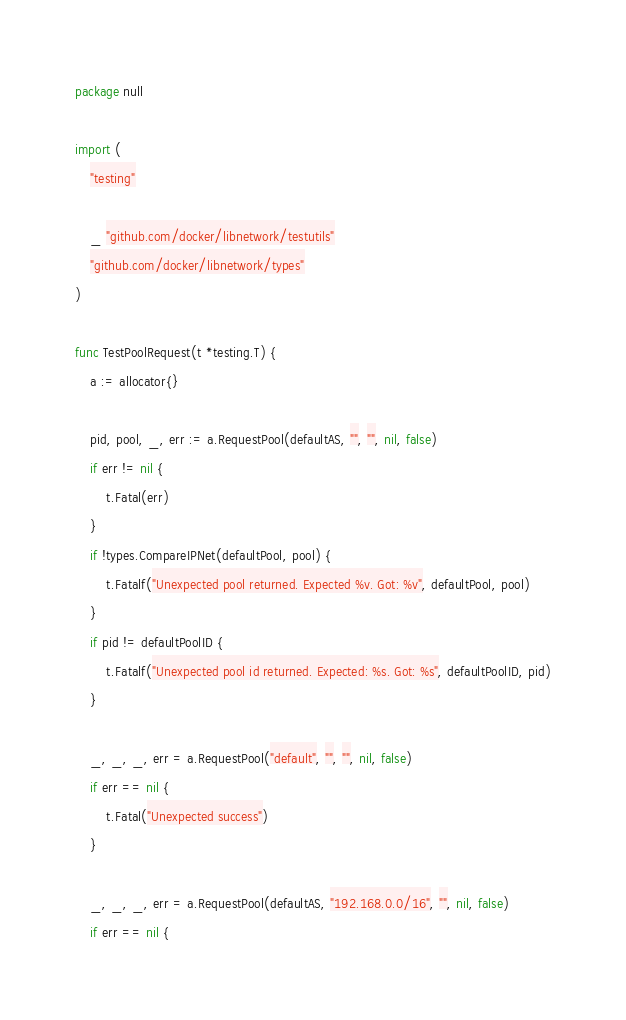<code> <loc_0><loc_0><loc_500><loc_500><_Go_>package null

import (
	"testing"

	_ "github.com/docker/libnetwork/testutils"
	"github.com/docker/libnetwork/types"
)

func TestPoolRequest(t *testing.T) {
	a := allocator{}

	pid, pool, _, err := a.RequestPool(defaultAS, "", "", nil, false)
	if err != nil {
		t.Fatal(err)
	}
	if !types.CompareIPNet(defaultPool, pool) {
		t.Fatalf("Unexpected pool returned. Expected %v. Got: %v", defaultPool, pool)
	}
	if pid != defaultPoolID {
		t.Fatalf("Unexpected pool id returned. Expected: %s. Got: %s", defaultPoolID, pid)
	}

	_, _, _, err = a.RequestPool("default", "", "", nil, false)
	if err == nil {
		t.Fatal("Unexpected success")
	}

	_, _, _, err = a.RequestPool(defaultAS, "192.168.0.0/16", "", nil, false)
	if err == nil {</code> 